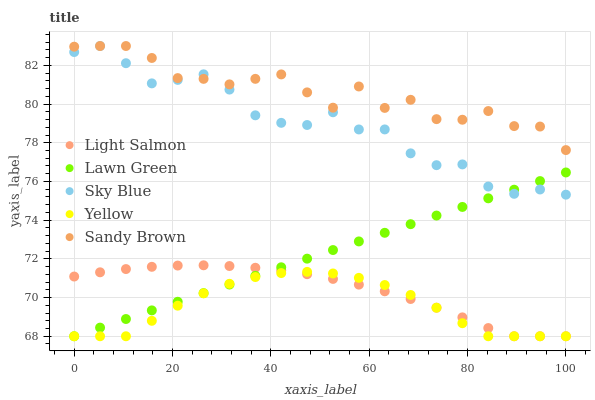Does Yellow have the minimum area under the curve?
Answer yes or no. Yes. Does Sandy Brown have the maximum area under the curve?
Answer yes or no. Yes. Does Light Salmon have the minimum area under the curve?
Answer yes or no. No. Does Light Salmon have the maximum area under the curve?
Answer yes or no. No. Is Lawn Green the smoothest?
Answer yes or no. Yes. Is Sandy Brown the roughest?
Answer yes or no. Yes. Is Light Salmon the smoothest?
Answer yes or no. No. Is Light Salmon the roughest?
Answer yes or no. No. Does Lawn Green have the lowest value?
Answer yes or no. Yes. Does Sandy Brown have the lowest value?
Answer yes or no. No. Does Sky Blue have the highest value?
Answer yes or no. Yes. Does Light Salmon have the highest value?
Answer yes or no. No. Is Lawn Green less than Sandy Brown?
Answer yes or no. Yes. Is Sky Blue greater than Light Salmon?
Answer yes or no. Yes. Does Sky Blue intersect Lawn Green?
Answer yes or no. Yes. Is Sky Blue less than Lawn Green?
Answer yes or no. No. Is Sky Blue greater than Lawn Green?
Answer yes or no. No. Does Lawn Green intersect Sandy Brown?
Answer yes or no. No. 